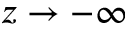<formula> <loc_0><loc_0><loc_500><loc_500>z \rightarrow - \infty</formula> 